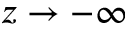<formula> <loc_0><loc_0><loc_500><loc_500>z \rightarrow - \infty</formula> 